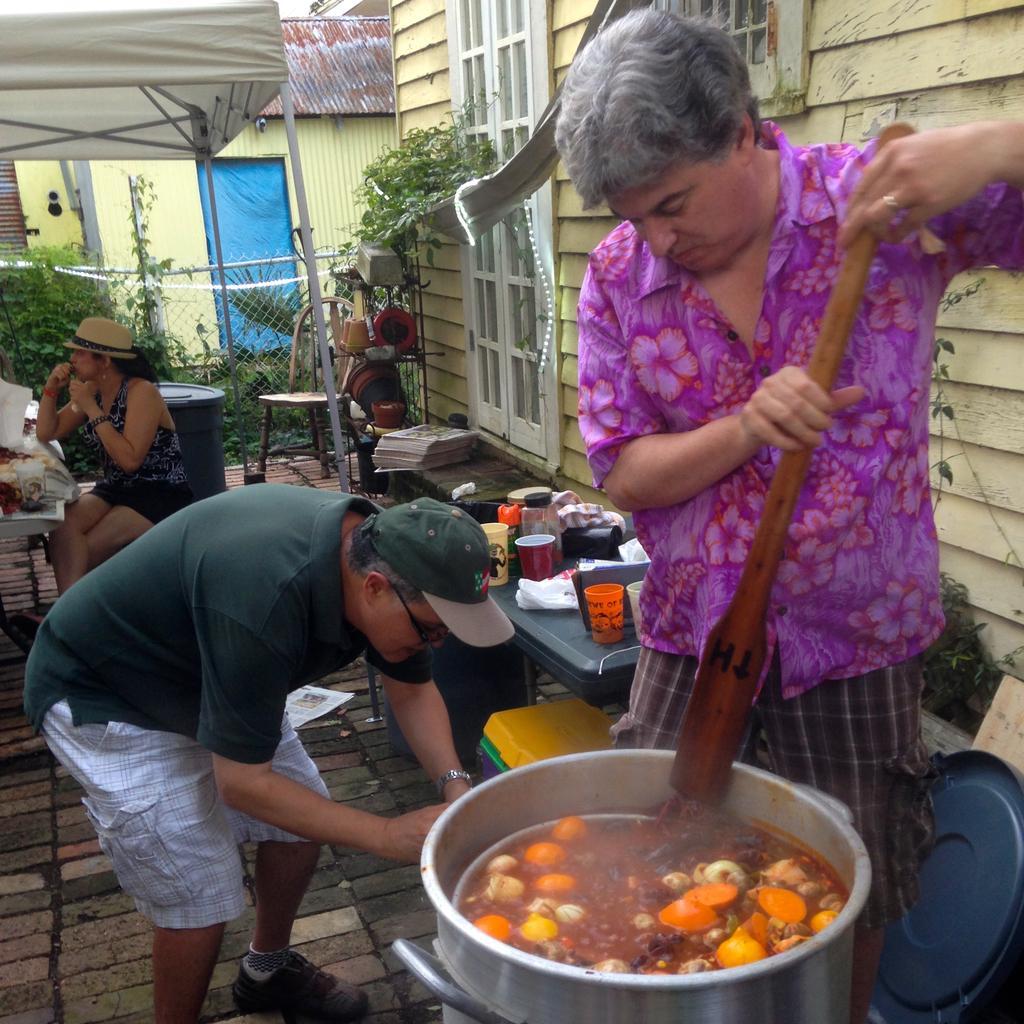Can you describe this image briefly? In this image I can see a person wearing pink colored shirt is standing and holding a stick in his hand. I can see a container in front of him with a food item in it. I can see another person wearing green t shirt, white shirt and green hat is standing. In the background I can see a woman sitting on a chair, few cups, few bottles and few other objects on the desk, a house which is cream in color, the white colored door, a white colored tent and few other objects. 